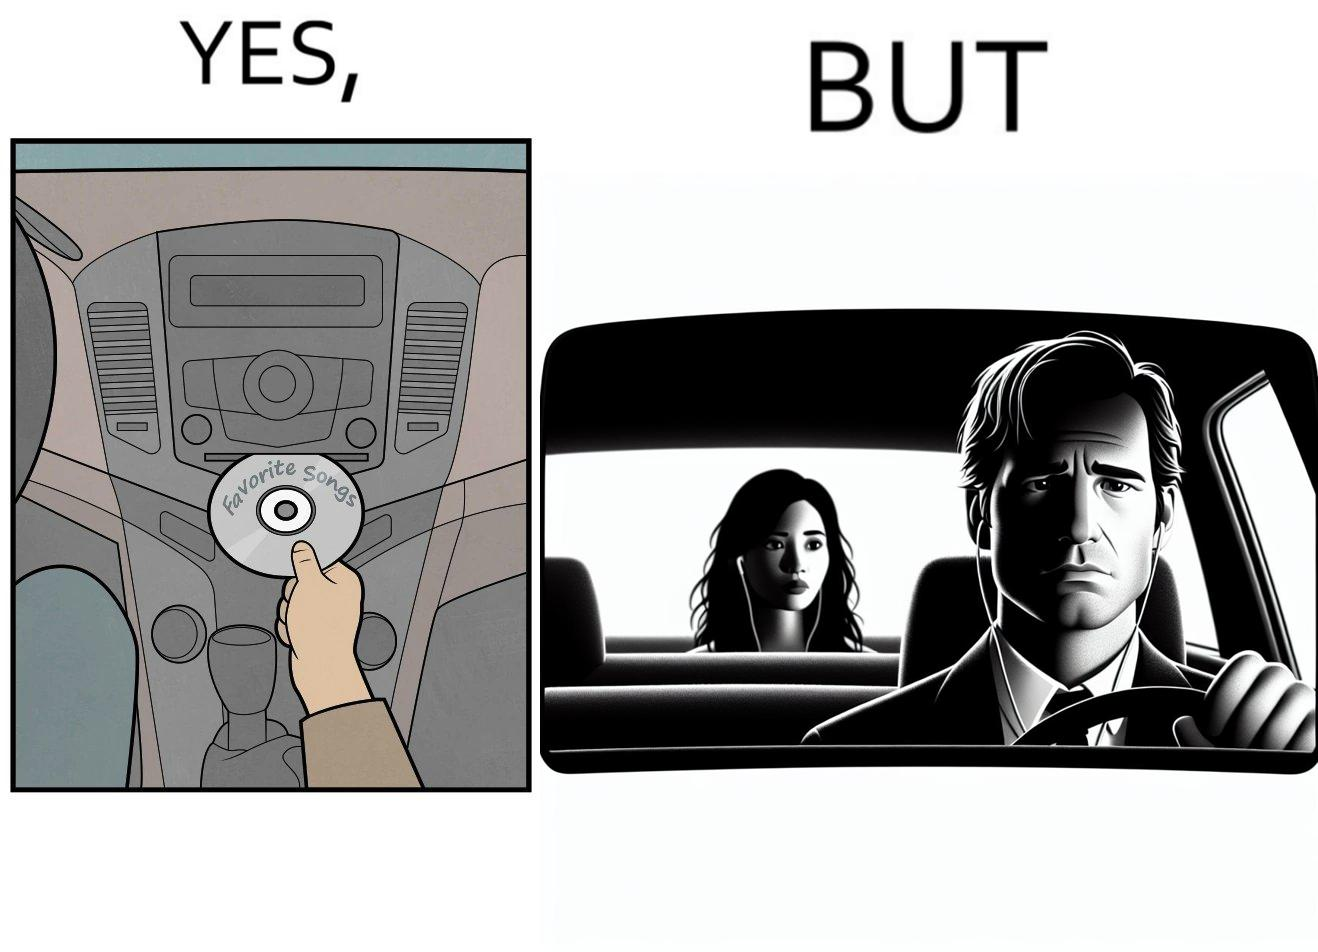Is this image satirical or non-satirical? Yes, this image is satirical. 